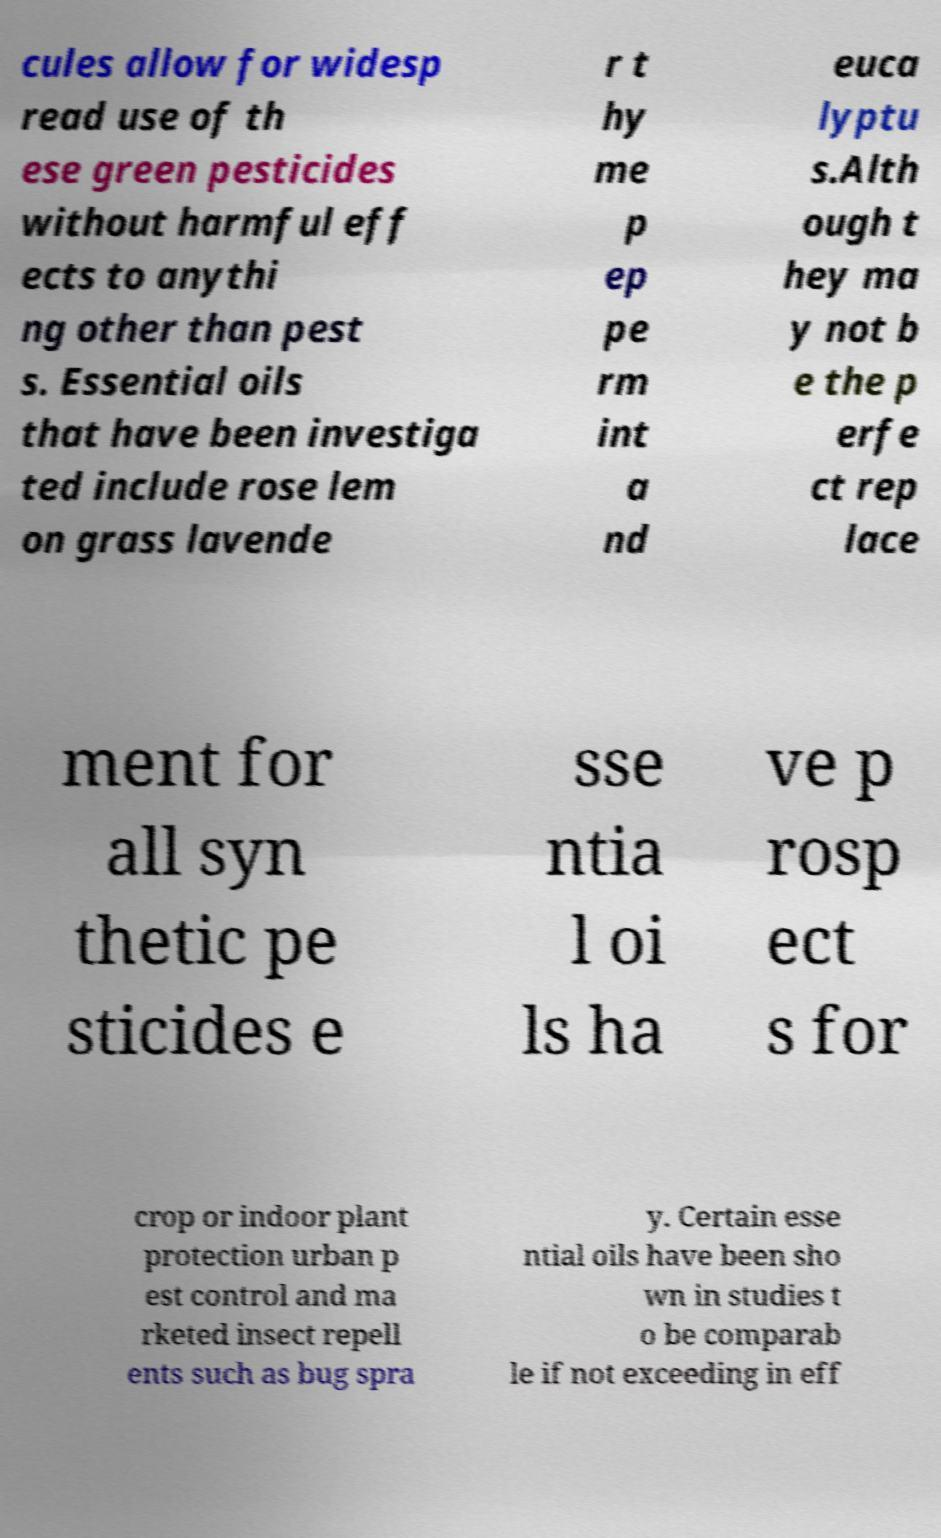Could you assist in decoding the text presented in this image and type it out clearly? cules allow for widesp read use of th ese green pesticides without harmful eff ects to anythi ng other than pest s. Essential oils that have been investiga ted include rose lem on grass lavende r t hy me p ep pe rm int a nd euca lyptu s.Alth ough t hey ma y not b e the p erfe ct rep lace ment for all syn thetic pe sticides e sse ntia l oi ls ha ve p rosp ect s for crop or indoor plant protection urban p est control and ma rketed insect repell ents such as bug spra y. Certain esse ntial oils have been sho wn in studies t o be comparab le if not exceeding in eff 